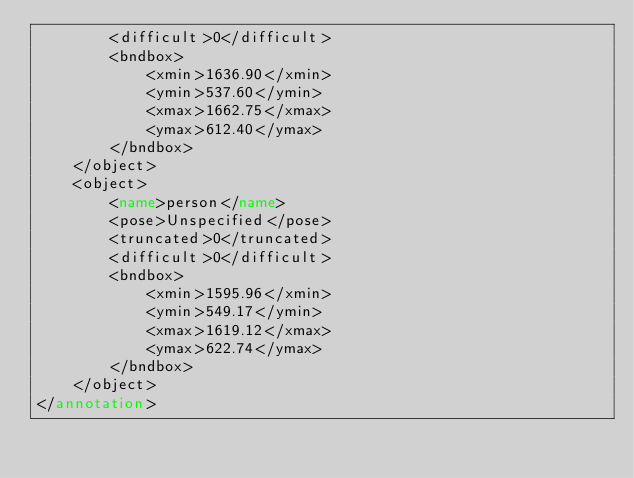Convert code to text. <code><loc_0><loc_0><loc_500><loc_500><_XML_>		<difficult>0</difficult>
		<bndbox>
			<xmin>1636.90</xmin>
			<ymin>537.60</ymin>
			<xmax>1662.75</xmax>
			<ymax>612.40</ymax>
		</bndbox>
	</object>
	<object>
		<name>person</name>
		<pose>Unspecified</pose>
		<truncated>0</truncated>
		<difficult>0</difficult>
		<bndbox>
			<xmin>1595.96</xmin>
			<ymin>549.17</ymin>
			<xmax>1619.12</xmax>
			<ymax>622.74</ymax>
		</bndbox>
	</object>
</annotation>
</code> 